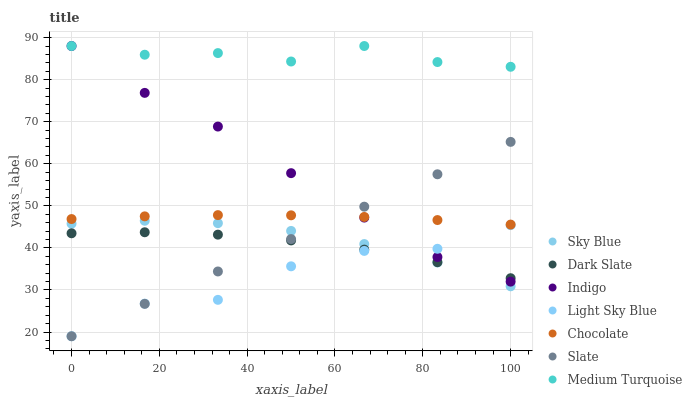Does Light Sky Blue have the minimum area under the curve?
Answer yes or no. Yes. Does Medium Turquoise have the maximum area under the curve?
Answer yes or no. Yes. Does Slate have the minimum area under the curve?
Answer yes or no. No. Does Slate have the maximum area under the curve?
Answer yes or no. No. Is Slate the smoothest?
Answer yes or no. Yes. Is Light Sky Blue the roughest?
Answer yes or no. Yes. Is Chocolate the smoothest?
Answer yes or no. No. Is Chocolate the roughest?
Answer yes or no. No. Does Slate have the lowest value?
Answer yes or no. Yes. Does Chocolate have the lowest value?
Answer yes or no. No. Does Medium Turquoise have the highest value?
Answer yes or no. Yes. Does Slate have the highest value?
Answer yes or no. No. Is Slate less than Medium Turquoise?
Answer yes or no. Yes. Is Medium Turquoise greater than Sky Blue?
Answer yes or no. Yes. Does Chocolate intersect Slate?
Answer yes or no. Yes. Is Chocolate less than Slate?
Answer yes or no. No. Is Chocolate greater than Slate?
Answer yes or no. No. Does Slate intersect Medium Turquoise?
Answer yes or no. No. 